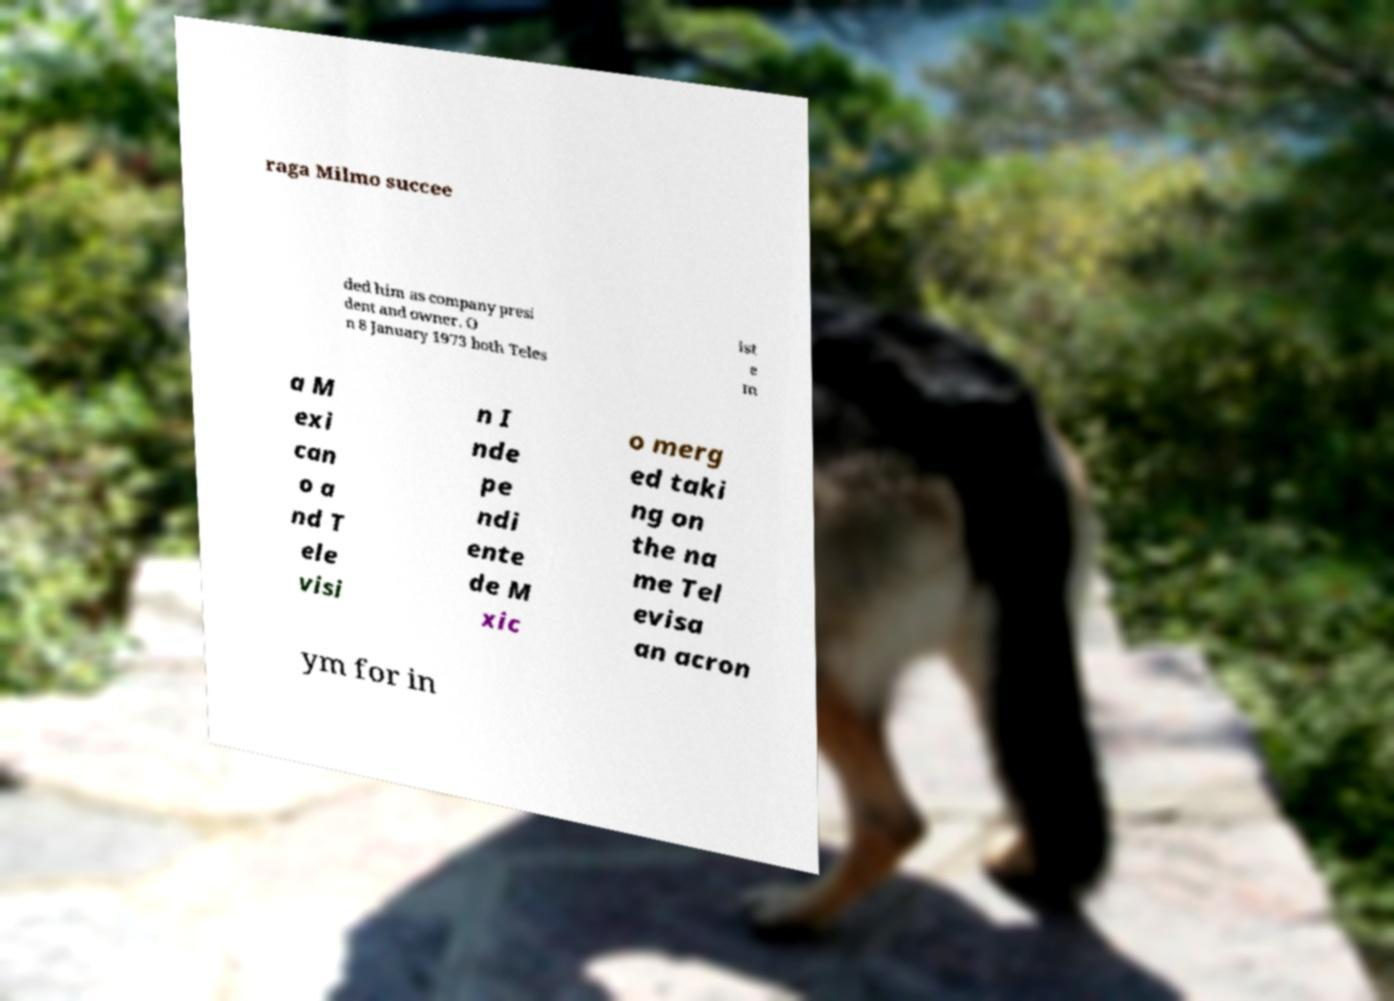Please read and relay the text visible in this image. What does it say? raga Milmo succee ded him as company presi dent and owner. O n 8 January 1973 both Teles ist e m a M exi can o a nd T ele visi n I nde pe ndi ente de M xic o merg ed taki ng on the na me Tel evisa an acron ym for in 